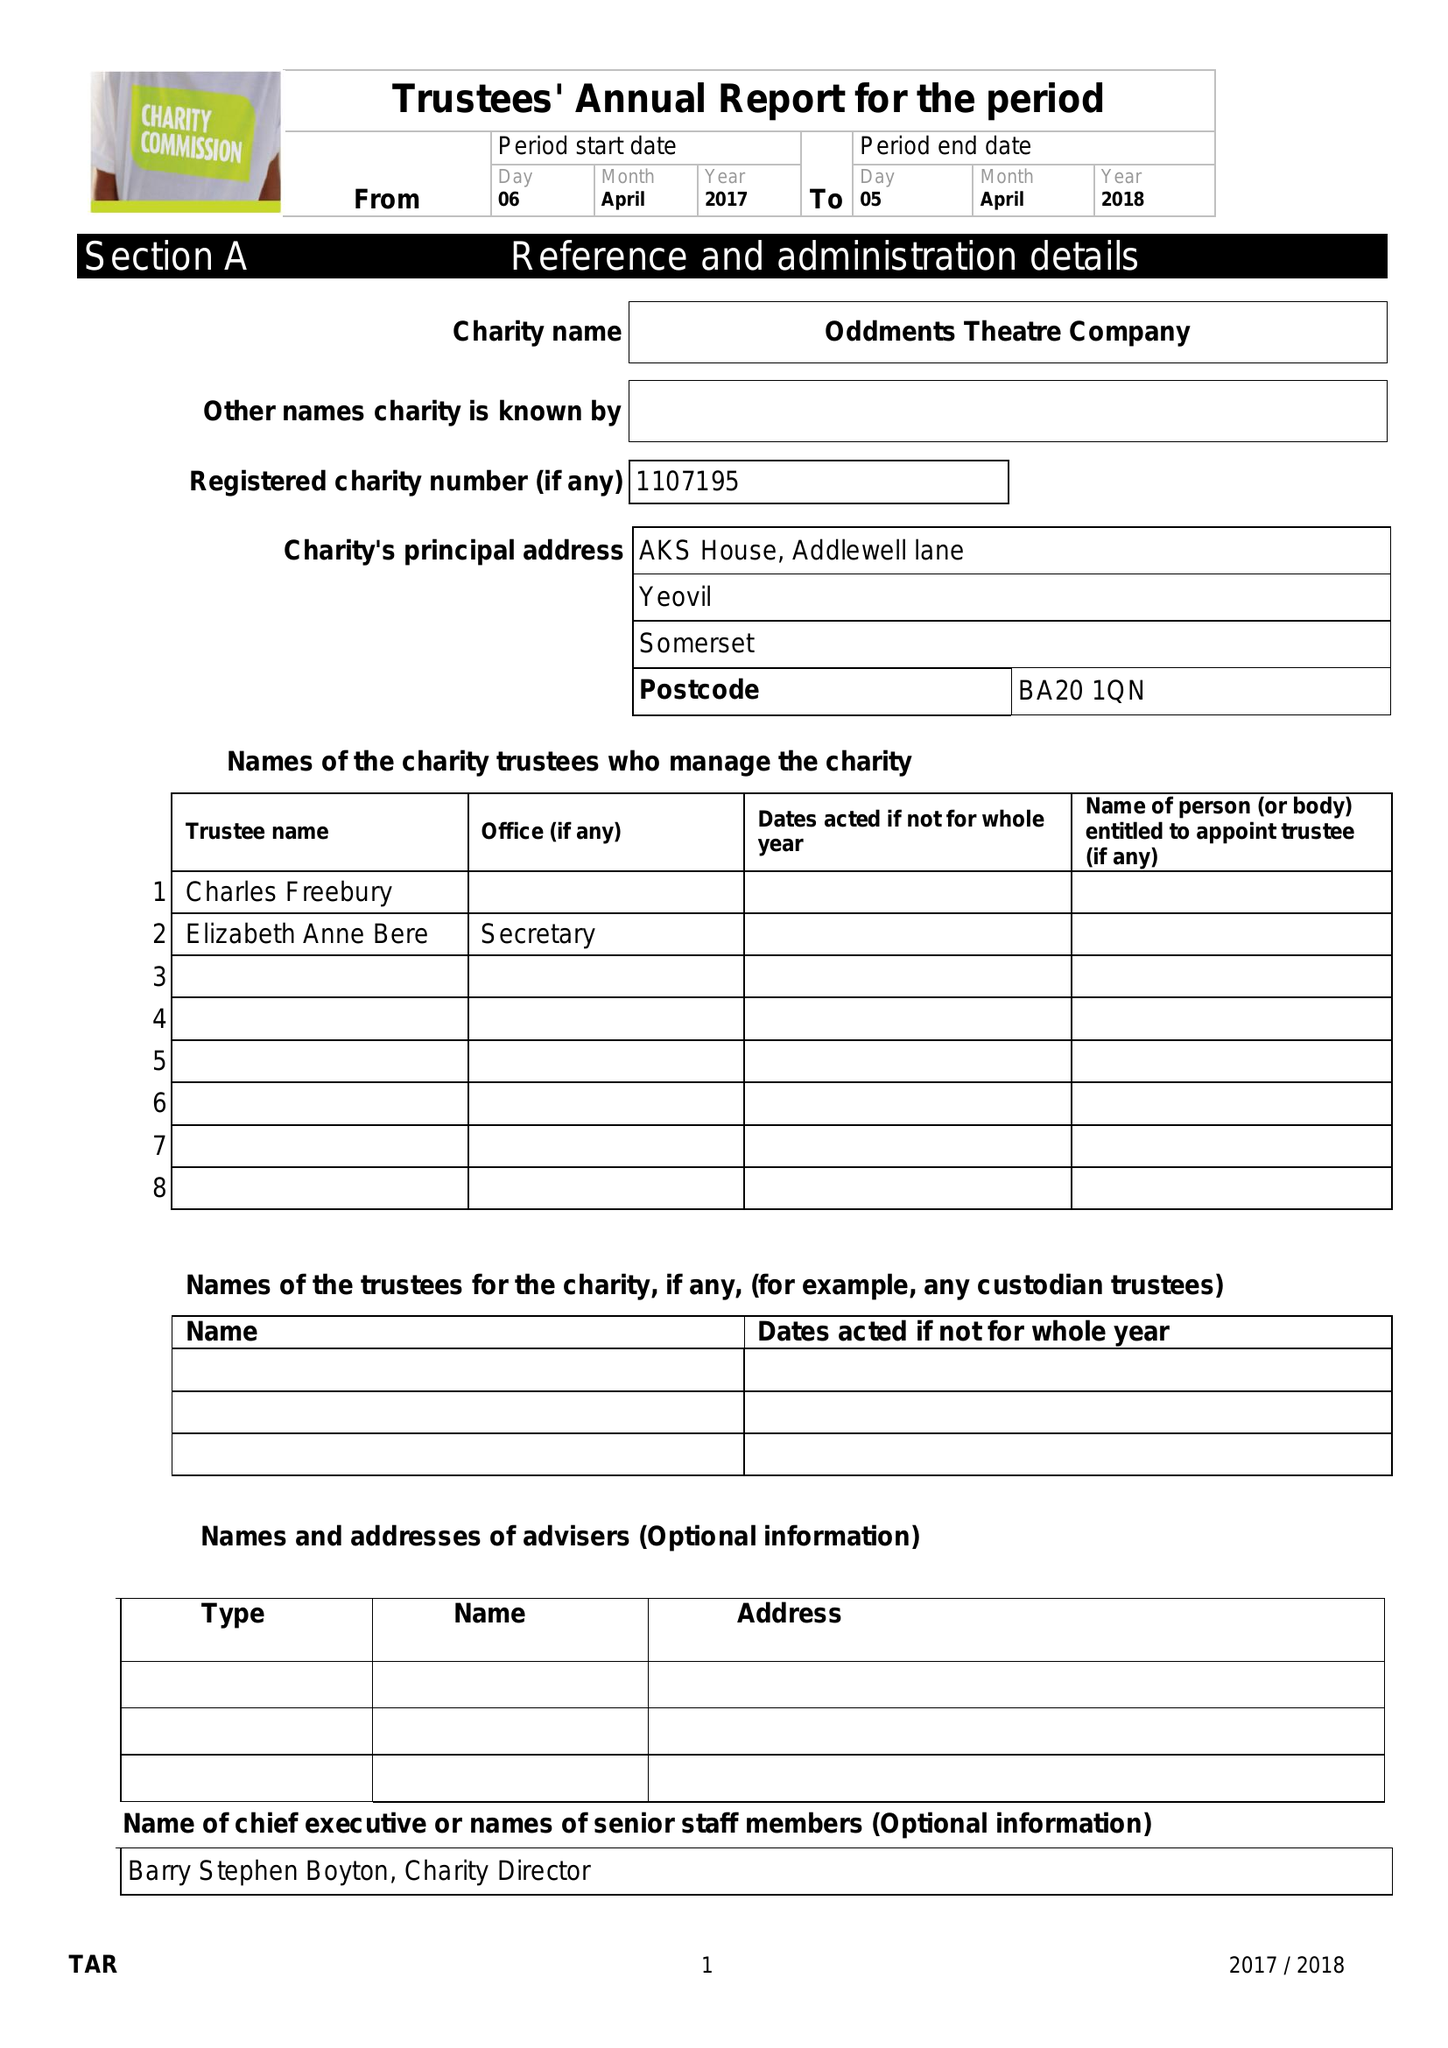What is the value for the report_date?
Answer the question using a single word or phrase. 2018-04-05 